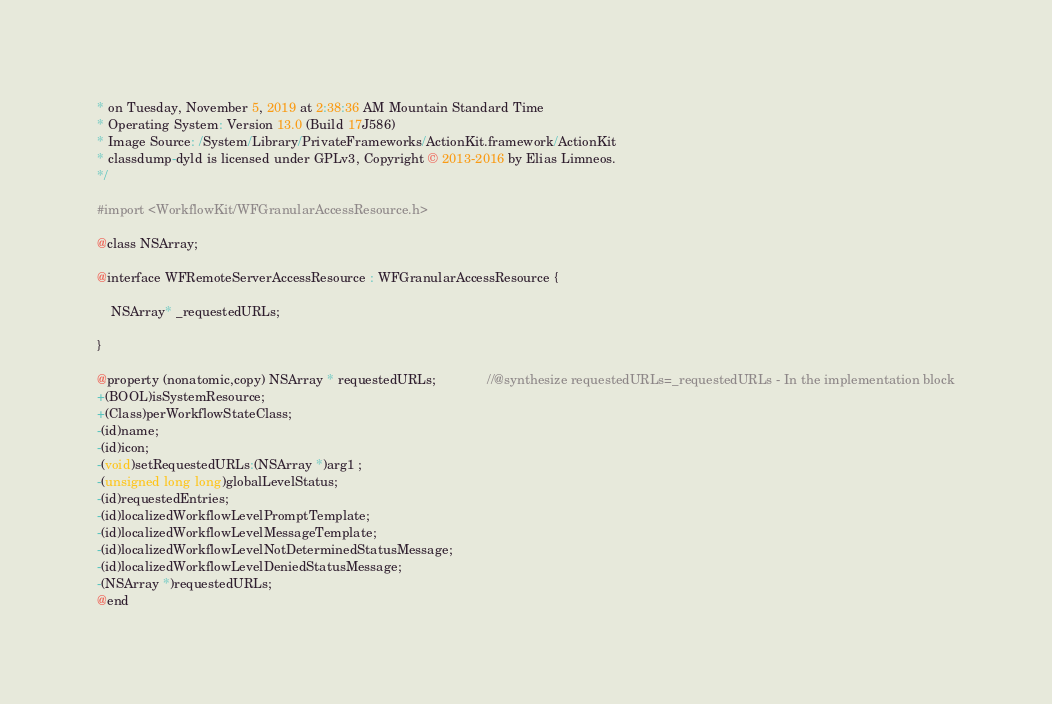<code> <loc_0><loc_0><loc_500><loc_500><_C_>* on Tuesday, November 5, 2019 at 2:38:36 AM Mountain Standard Time
* Operating System: Version 13.0 (Build 17J586)
* Image Source: /System/Library/PrivateFrameworks/ActionKit.framework/ActionKit
* classdump-dyld is licensed under GPLv3, Copyright © 2013-2016 by Elias Limneos.
*/

#import <WorkflowKit/WFGranularAccessResource.h>

@class NSArray;

@interface WFRemoteServerAccessResource : WFGranularAccessResource {

	NSArray* _requestedURLs;

}

@property (nonatomic,copy) NSArray * requestedURLs;              //@synthesize requestedURLs=_requestedURLs - In the implementation block
+(BOOL)isSystemResource;
+(Class)perWorkflowStateClass;
-(id)name;
-(id)icon;
-(void)setRequestedURLs:(NSArray *)arg1 ;
-(unsigned long long)globalLevelStatus;
-(id)requestedEntries;
-(id)localizedWorkflowLevelPromptTemplate;
-(id)localizedWorkflowLevelMessageTemplate;
-(id)localizedWorkflowLevelNotDeterminedStatusMessage;
-(id)localizedWorkflowLevelDeniedStatusMessage;
-(NSArray *)requestedURLs;
@end

</code> 